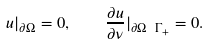<formula> <loc_0><loc_0><loc_500><loc_500>u | _ { \partial \Omega } = 0 , \quad \frac { \partial u } { \partial \nu } | _ { \partial \Omega \ \Gamma _ { + } } = 0 .</formula> 